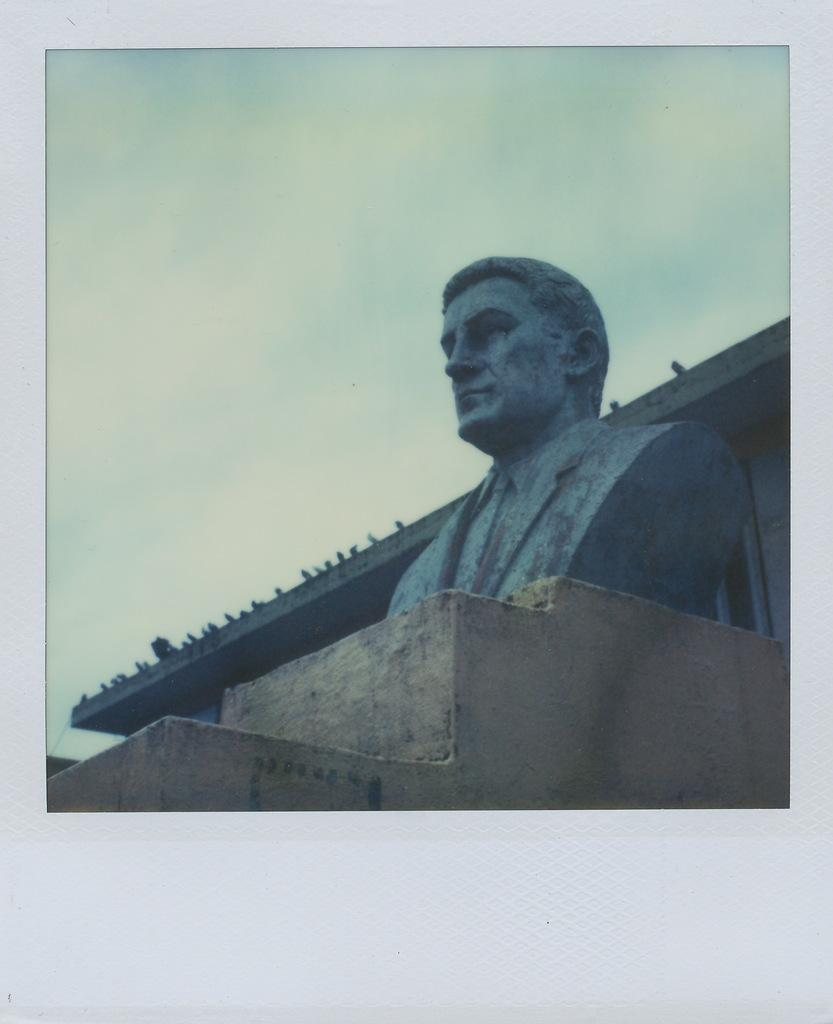What is the main subject in the foreground of the image? There is a sculpture on a stone surface in the foreground of the image. What can be seen in the background of the image? There is a roof of a building in the background of the image. What is visible above the building in the image? The sky is visible in the background of the image. What is the condition of the sky in the image? There are clouds in the sky. How does the sculpture express love in the image? The sculpture does not express love in the image, as it is a static object and there is no indication of emotion or sentiment. 